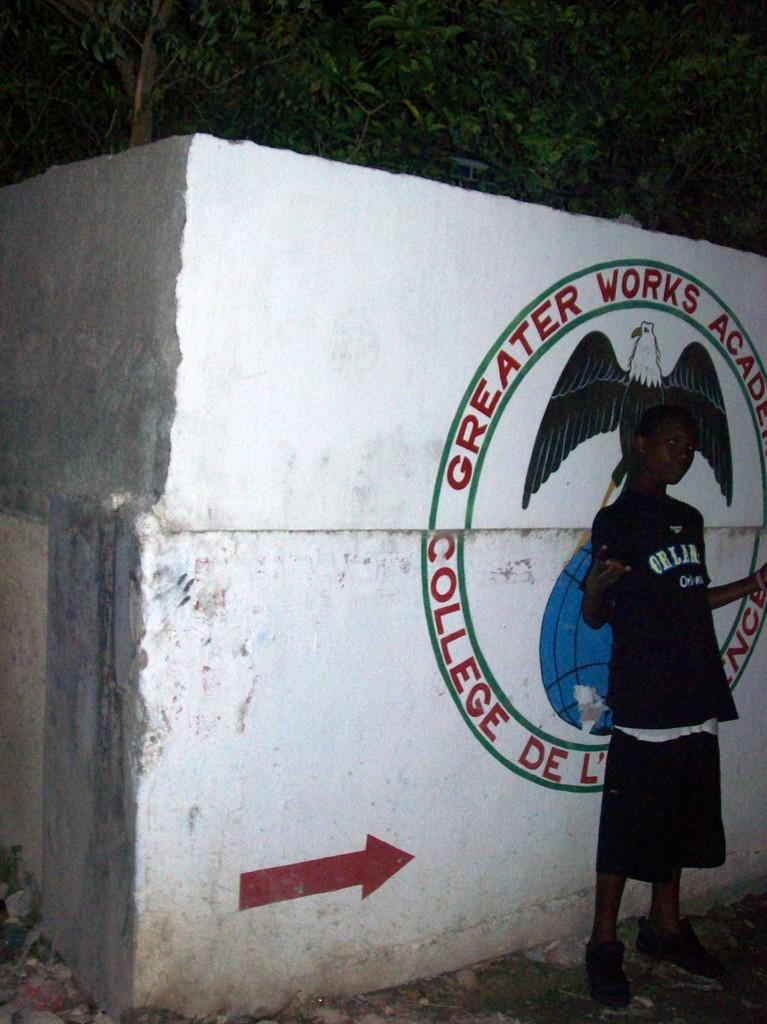<image>
Create a compact narrative representing the image presented. A boy dressed in black standing in front of a sign that said greater works with an eagle symbol. 